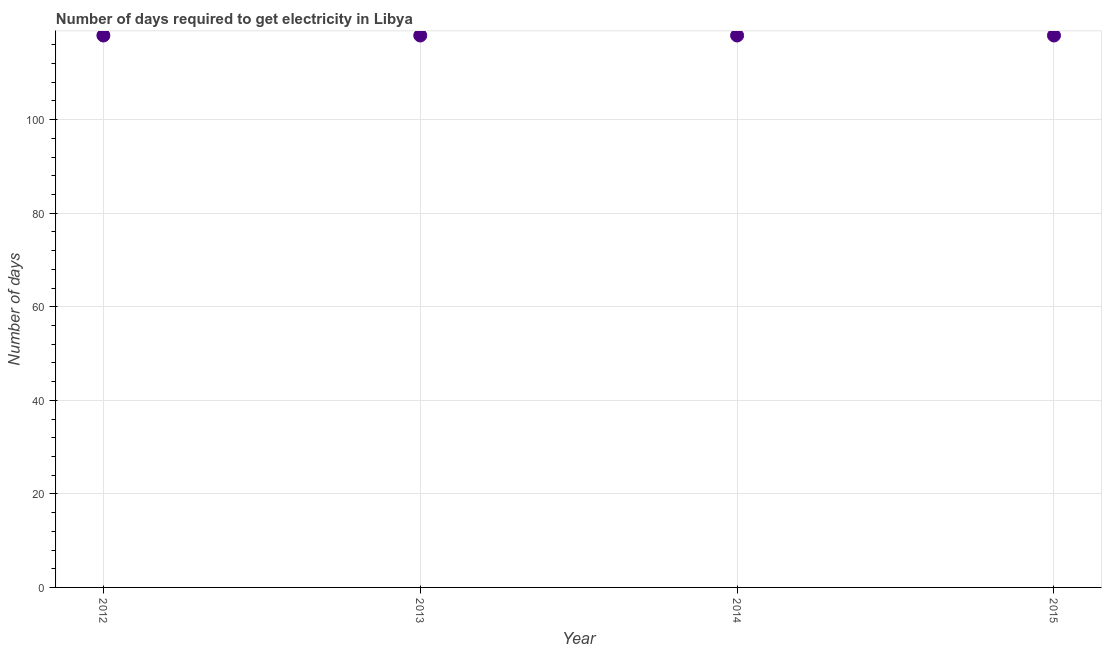What is the time to get electricity in 2013?
Ensure brevity in your answer.  118. Across all years, what is the maximum time to get electricity?
Give a very brief answer. 118. Across all years, what is the minimum time to get electricity?
Make the answer very short. 118. In which year was the time to get electricity minimum?
Provide a short and direct response. 2012. What is the sum of the time to get electricity?
Provide a succinct answer. 472. What is the difference between the time to get electricity in 2012 and 2014?
Make the answer very short. 0. What is the average time to get electricity per year?
Provide a short and direct response. 118. What is the median time to get electricity?
Make the answer very short. 118. In how many years, is the time to get electricity greater than 104 ?
Your answer should be compact. 4. What is the ratio of the time to get electricity in 2013 to that in 2014?
Offer a terse response. 1. Is the difference between the time to get electricity in 2012 and 2014 greater than the difference between any two years?
Offer a terse response. Yes. Is the sum of the time to get electricity in 2013 and 2015 greater than the maximum time to get electricity across all years?
Keep it short and to the point. Yes. In how many years, is the time to get electricity greater than the average time to get electricity taken over all years?
Offer a very short reply. 0. Does the time to get electricity monotonically increase over the years?
Make the answer very short. No. How many dotlines are there?
Keep it short and to the point. 1. How many years are there in the graph?
Ensure brevity in your answer.  4. Are the values on the major ticks of Y-axis written in scientific E-notation?
Provide a short and direct response. No. Does the graph contain any zero values?
Your response must be concise. No. What is the title of the graph?
Your answer should be compact. Number of days required to get electricity in Libya. What is the label or title of the X-axis?
Make the answer very short. Year. What is the label or title of the Y-axis?
Ensure brevity in your answer.  Number of days. What is the Number of days in 2012?
Give a very brief answer. 118. What is the Number of days in 2013?
Offer a very short reply. 118. What is the Number of days in 2014?
Provide a succinct answer. 118. What is the Number of days in 2015?
Keep it short and to the point. 118. What is the difference between the Number of days in 2012 and 2013?
Your answer should be very brief. 0. What is the difference between the Number of days in 2013 and 2014?
Give a very brief answer. 0. What is the ratio of the Number of days in 2012 to that in 2013?
Offer a terse response. 1. 